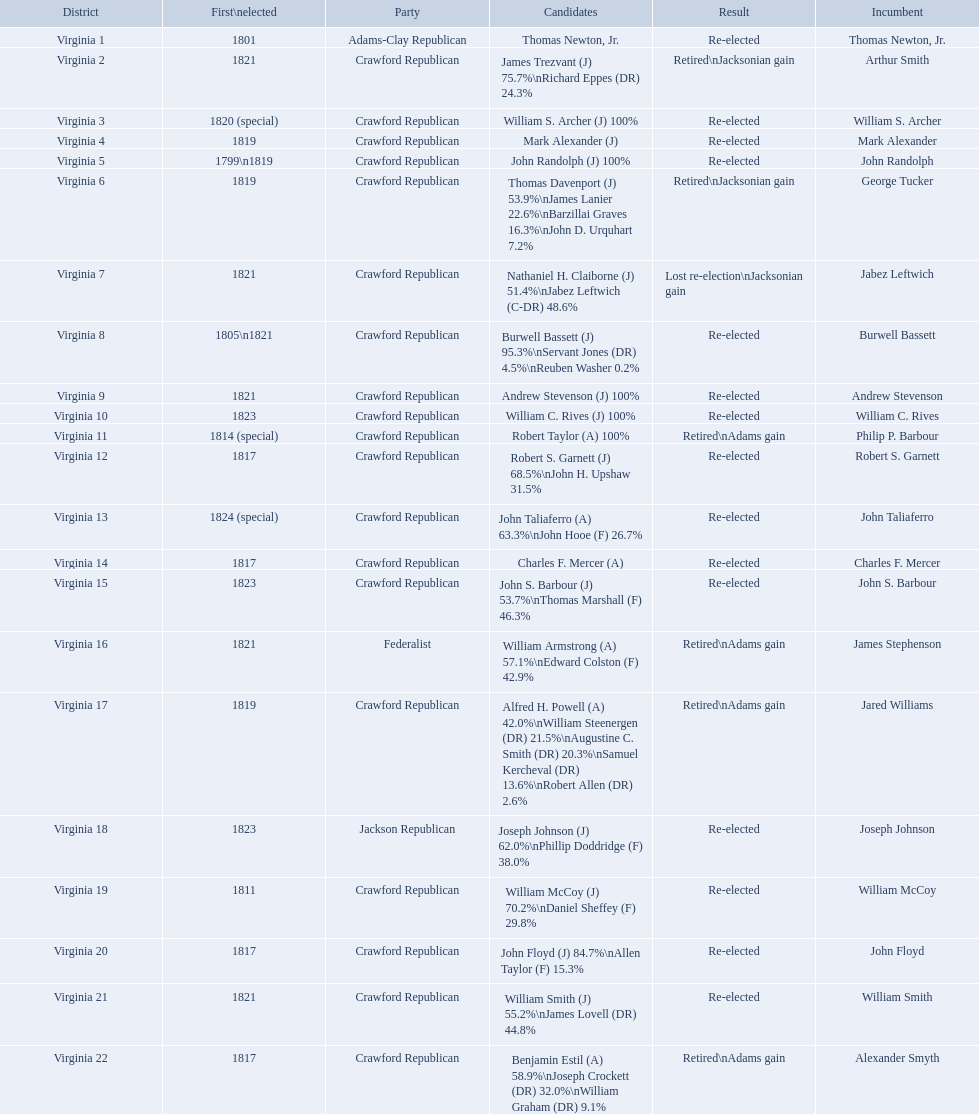Which incumbents belonged to the crawford republican party? Arthur Smith, William S. Archer, Mark Alexander, John Randolph, George Tucker, Jabez Leftwich, Burwell Bassett, Andrew Stevenson, William C. Rives, Philip P. Barbour, Robert S. Garnett, John Taliaferro, Charles F. Mercer, John S. Barbour, Jared Williams, William McCoy, John Floyd, William Smith, Alexander Smyth. Which of these incumbents were first elected in 1821? Arthur Smith, Jabez Leftwich, Andrew Stevenson, William Smith. Which of these incumbents have a last name of smith? Arthur Smith, William Smith. Which of these two were not re-elected? Arthur Smith. 